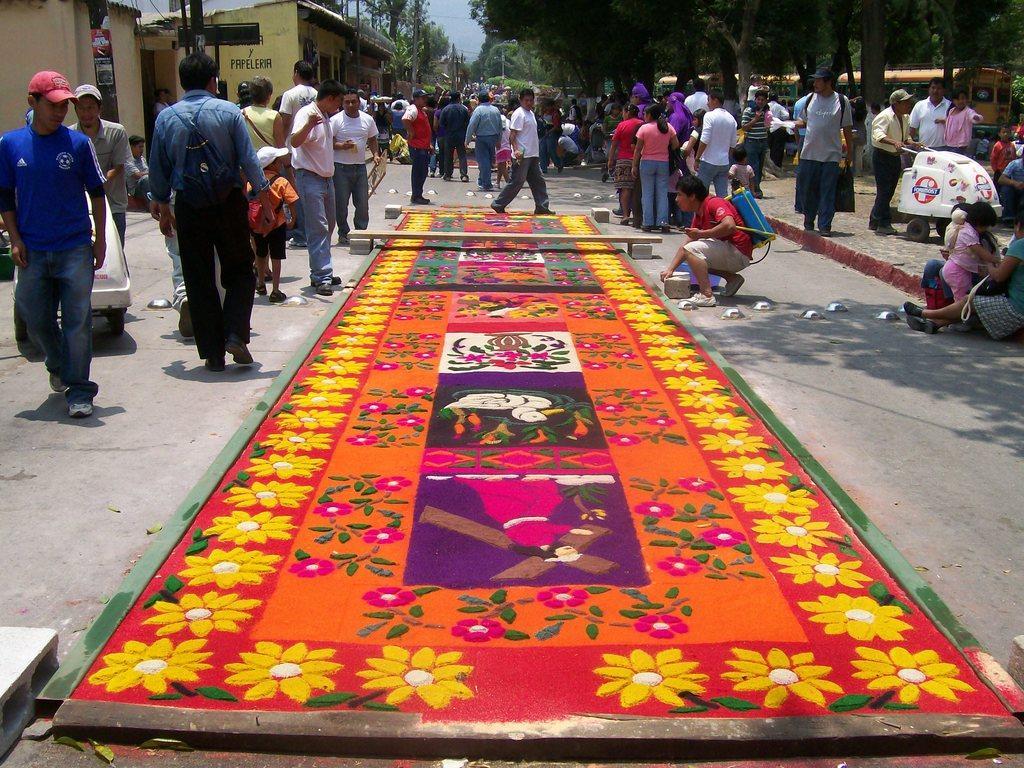Describe this image in one or two sentences. In this image, we can see some people standing and there are some people walking, we can see some trees, there is a bus at the right side, we can see homes. 